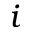Convert formula to latex. <formula><loc_0><loc_0><loc_500><loc_500>i</formula> 